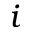Convert formula to latex. <formula><loc_0><loc_0><loc_500><loc_500>i</formula> 